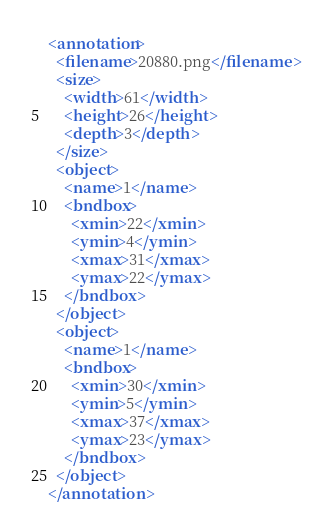Convert code to text. <code><loc_0><loc_0><loc_500><loc_500><_XML_><annotation>
  <filename>20880.png</filename>
  <size>
    <width>61</width>
    <height>26</height>
    <depth>3</depth>
  </size>
  <object>
    <name>1</name>
    <bndbox>
      <xmin>22</xmin>
      <ymin>4</ymin>
      <xmax>31</xmax>
      <ymax>22</ymax>
    </bndbox>
  </object>
  <object>
    <name>1</name>
    <bndbox>
      <xmin>30</xmin>
      <ymin>5</ymin>
      <xmax>37</xmax>
      <ymax>23</ymax>
    </bndbox>
  </object>
</annotation>
</code> 